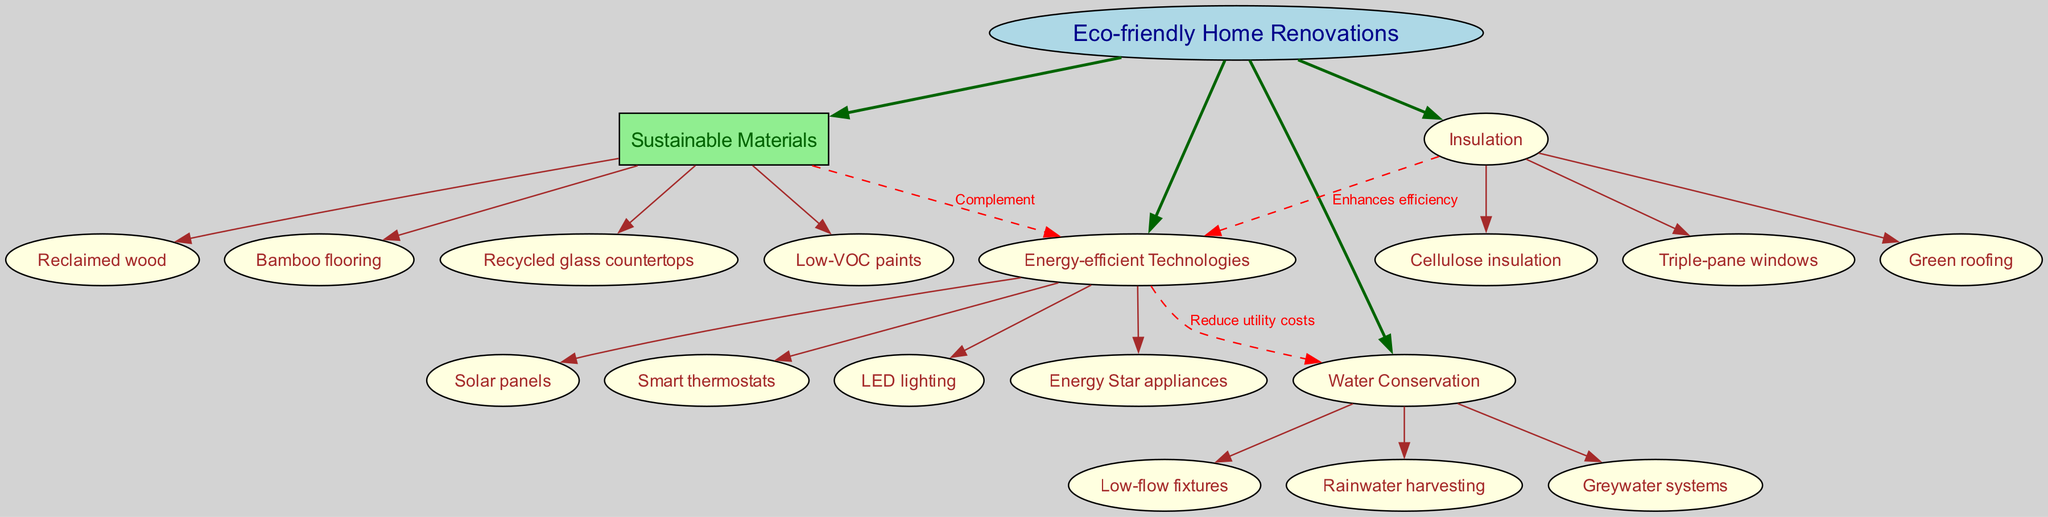What is the central concept of the diagram? The central concept is clearly labeled at the top of the diagram and indicates the main theme or focus, which is "Eco-friendly Home Renovations."
Answer: Eco-friendly Home Renovations How many main branches are there? By counting the branches stemming from the central concept, there are a total of four main branches displayed in the diagram.
Answer: 4 What are the sub-branches under "Sustainable Materials"? The sub-branches are connected to "Sustainable Materials," and include several specific types, which can be directly read from the diagram.
Answer: Reclaimed wood, Bamboo flooring, Recycled glass countertops, Low-VOC paints What is the relationship label between "Sustainable Materials" and "Energy-efficient Technologies"? The diagram provides a dashed line with a label indicating the type of relationship between these two branches, suggesting how they interact with one another.
Answer: Complement Which energy-efficient technology is directly mentioned in the diagram? The sub-branches under "Energy-efficient Technologies" will show several specific technologies that are labeled and illustrated in the diagram.
Answer: Solar panels, Smart thermostats, LED lighting, Energy Star appliances How do "Energy-efficient Technologies" relate to "Water Conservation"? The diagram shows a directional relationship with a label, which indicates how "Energy-efficient Technologies" influence "Water Conservation," showcasing their interaction in the context of home renovations.
Answer: Reduce utility costs Which insulation option enhances the efficiency of "Energy-efficient Technologies"? The sub-branches under "Insulation" contain specific options that improve the effectiveness of the energy-efficient technologies, as indicated by the connecting line in the diagram.
Answer: Cellulose insulation, Triple-pane windows, Green roofing What type of fixtures are included in the "Water Conservation" sub-branch? The diagram displays specific technologies focused on water-saving measures included in the "Water Conservation" category, directly read through its sub-branches label.
Answer: Low-flow fixtures What is one example of a sustainable material listed in the diagram? The sub-branches under "Sustainable Materials" contain various examples, any of which would provide direct answers to the question regarding sustainable materials in the diagram.
Answer: Reclaimed wood 